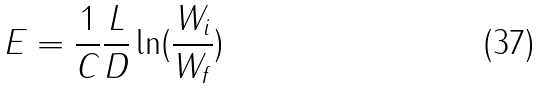<formula> <loc_0><loc_0><loc_500><loc_500>E = \frac { 1 } { C } \frac { L } { D } \ln ( \frac { W _ { i } } { W _ { f } } )</formula> 